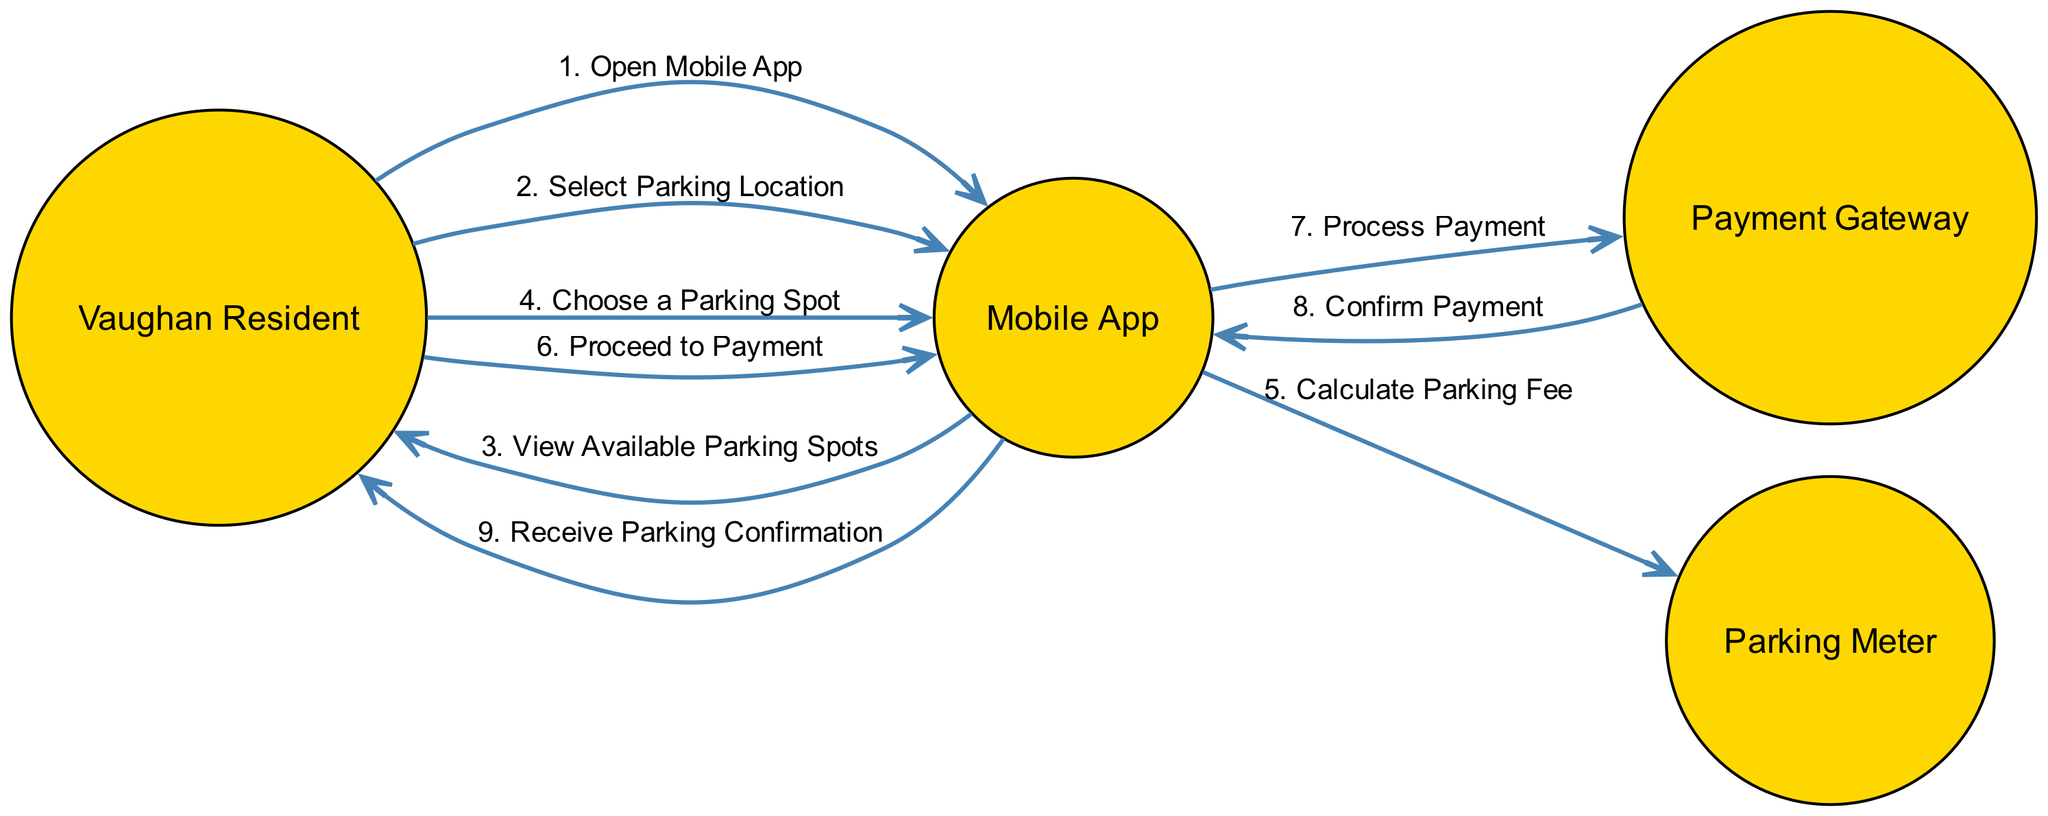What is the first action in the sequence? The first action listed in the interactions is "Open Mobile App," which is initiated by the Vaughan Resident and received by the Mobile App.
Answer: Open Mobile App How many actors are involved in this sequence? The diagram includes four actors: Vaughan Resident, Mobile App, Payment Gateway, and Parking Meter. Counting these gives a total of four actors.
Answer: Four What action follows "Choose a Parking Spot"? After the action "Choose a Parking Spot," the next action in the sequence is "Calculate Parking Fee," which receives input from the Mobile App to the Parking Meter.
Answer: Calculate Parking Fee Who confirms the payment in the sequence? The Payment Gateway is responsible for confirming the payment after processing it, sending this confirmation back to the Mobile App.
Answer: Payment Gateway Which actor initiates the payment process? The Vaughan Resident initiates the payment process with the action "Proceed to Payment," directing this action to the Mobile App for further steps.
Answer: Vaughan Resident How many steps are there in the entire interaction sequence? The interaction sequence consists of nine steps, as indicated by the numbered actions from 1 to 9 in the diagram.
Answer: Nine Which actions involve the Mobile App as the receiver? The actions where the Mobile App is the receiver include "View Available Parking Spots," "Process Payment," and "Receive Parking Confirmation," among others. Upon reviewing the interactions, these actions are identified.
Answer: View Available Parking Spots, Process Payment, Receive Parking Confirmation What is the last action in the sequence? The last action listed in the sequence is "Receive Parking Confirmation," which is received by the Vaughan Resident from the Mobile App.
Answer: Receive Parking Confirmation What is the action that occurs after "Process Payment"? After "Process Payment," the next action is "Confirm Payment," which is initiated by the Payment Gateway and sent back to the Mobile App.
Answer: Confirm Payment 